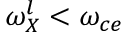Convert formula to latex. <formula><loc_0><loc_0><loc_500><loc_500>\omega _ { X } ^ { l } < \omega _ { c e }</formula> 